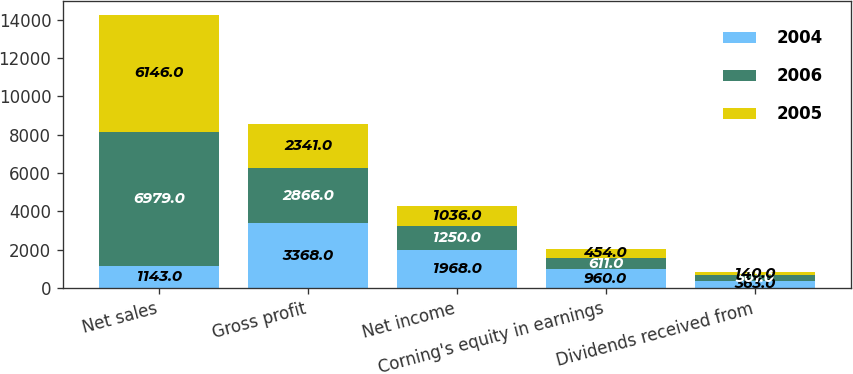<chart> <loc_0><loc_0><loc_500><loc_500><stacked_bar_chart><ecel><fcel>Net sales<fcel>Gross profit<fcel>Net income<fcel>Corning's equity in earnings<fcel>Dividends received from<nl><fcel>2004<fcel>1143<fcel>3368<fcel>1968<fcel>960<fcel>363<nl><fcel>2006<fcel>6979<fcel>2866<fcel>1250<fcel>611<fcel>301<nl><fcel>2005<fcel>6146<fcel>2341<fcel>1036<fcel>454<fcel>140<nl></chart> 